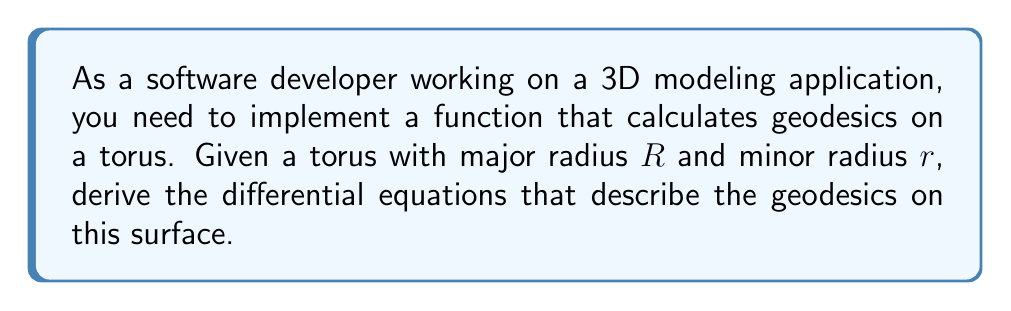Could you help me with this problem? Let's approach this step-by-step:

1) First, we need to parameterize the torus. A common parameterization is:
   $$x = (R + r\cos v)\cos u$$
   $$y = (R + r\cos v)\sin u$$
   $$z = r\sin v$$
   where $0 \leq u, v < 2\pi$

2) To find the geodesics, we need to use the Euler-Lagrange equations. The Lagrangian for a geodesic is:
   $$L = \sqrt{g_{11}(\dot{u})^2 + 2g_{12}\dot{u}\dot{v} + g_{22}(\dot{v})^2}$$
   where $g_{ij}$ are the components of the metric tensor.

3) Calculate the metric tensor components:
   $$g_{11} = (R + r\cos v)^2$$
   $$g_{12} = g_{21} = 0$$
   $$g_{22} = r^2$$

4) The Euler-Lagrange equations are:
   $$\frac{d}{dt}\left(\frac{\partial L}{\partial \dot{u}}\right) - \frac{\partial L}{\partial u} = 0$$
   $$\frac{d}{dt}\left(\frac{\partial L}{\partial \dot{v}}\right) - \frac{\partial L}{\partial v} = 0$$

5) After simplification, these equations become:
   $$(R + r\cos v)^2\ddot{u} + 2r(R + r\cos v)\sin v\dot{u}\dot{v} = 0$$
   $$r^2\ddot{v} - (R + r\cos v)r\sin v(\dot{u})^2 = 0$$

6) These are the differential equations that describe the geodesics on the torus.

7) To implement this in software, you would need to solve these differential equations numerically, using methods like Runge-Kutta or similar ODE solvers.
Answer: $$(R + r\cos v)^2\ddot{u} + 2r(R + r\cos v)\sin v\dot{u}\dot{v} = 0$$
$$r^2\ddot{v} - (R + r\cos v)r\sin v(\dot{u})^2 = 0$$ 